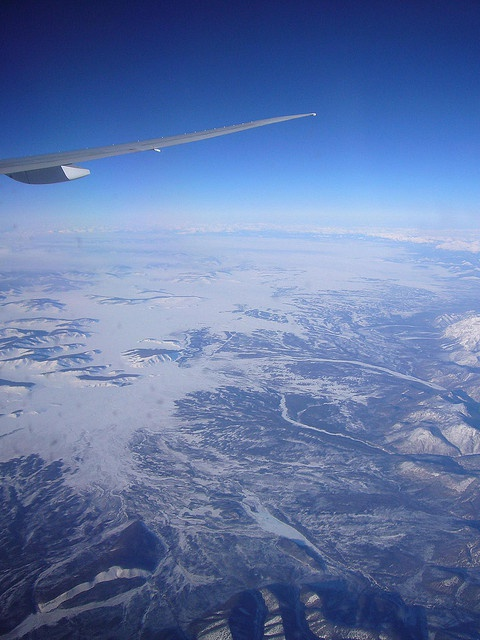Describe the objects in this image and their specific colors. I can see a airplane in navy and gray tones in this image. 